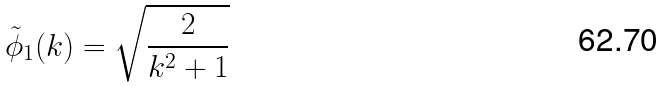Convert formula to latex. <formula><loc_0><loc_0><loc_500><loc_500>\tilde { \phi } _ { 1 } ( k ) = \sqrt { \frac { 2 } { k ^ { 2 } + 1 } }</formula> 